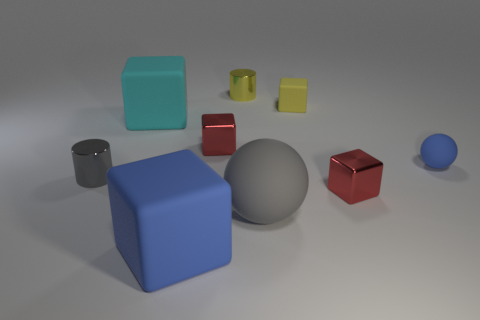The blue block is what size?
Make the answer very short. Large. Is the number of rubber cubes in front of the large gray matte thing greater than the number of large cyan matte objects?
Ensure brevity in your answer.  No. Is there anything else that is the same material as the small gray object?
Your answer should be very brief. Yes. There is a large thing that is in front of the large gray thing; is its color the same as the rubber block that is left of the large blue matte object?
Your response must be concise. No. The red thing that is left of the big thing right of the big block that is in front of the gray metallic cylinder is made of what material?
Make the answer very short. Metal. Are there more metal objects than brown balls?
Provide a short and direct response. Yes. Is there any other thing of the same color as the small matte cube?
Make the answer very short. Yes. What size is the cylinder that is the same material as the tiny gray thing?
Give a very brief answer. Small. What is the large blue block made of?
Offer a terse response. Rubber. What number of blue rubber balls are the same size as the cyan rubber object?
Make the answer very short. 0. 